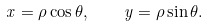<formula> <loc_0><loc_0><loc_500><loc_500>x = \rho \cos \theta , \quad y = \rho \sin \theta .</formula> 